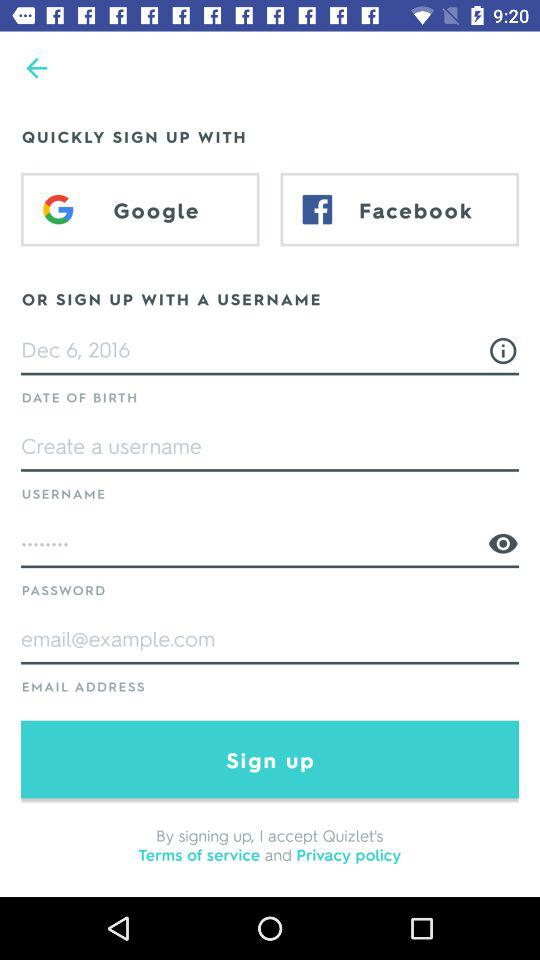Which accounts can I use to sign up? You can sign up with "Google", "Facebook" and "USERNAME". 